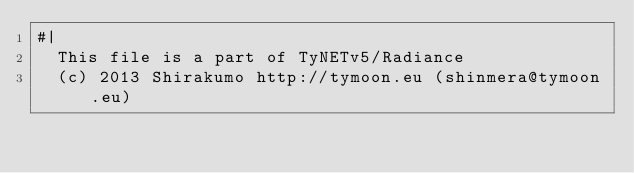Convert code to text. <code><loc_0><loc_0><loc_500><loc_500><_Lisp_>#|
  This file is a part of TyNETv5/Radiance
  (c) 2013 Shirakumo http://tymoon.eu (shinmera@tymoon.eu)</code> 